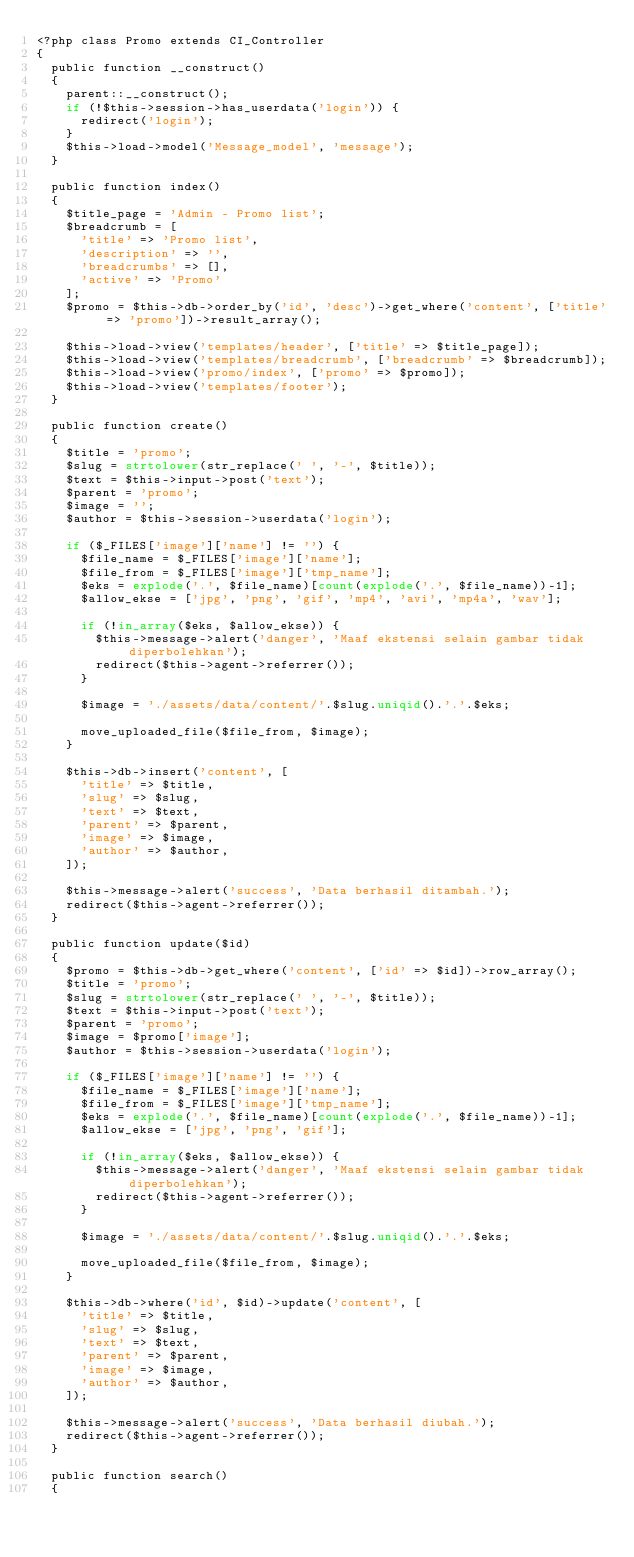Convert code to text. <code><loc_0><loc_0><loc_500><loc_500><_PHP_><?php class Promo extends CI_Controller
{
	public function __construct()
	{
		parent::__construct();
		if (!$this->session->has_userdata('login')) {
			redirect('login');
		}
		$this->load->model('Message_model', 'message');
	}

	public function index()
	{
		$title_page = 'Admin - Promo list';
    $breadcrumb = [
      'title' => 'Promo list',
      'description' => '',
      'breadcrumbs' => [],
      'active' => 'Promo'
    ];
    $promo = $this->db->order_by('id', 'desc')->get_where('content', ['title' => 'promo'])->result_array();

    $this->load->view('templates/header', ['title' => $title_page]);
    $this->load->view('templates/breadcrumb', ['breadcrumb' => $breadcrumb]);
    $this->load->view('promo/index', ['promo' => $promo]);
    $this->load->view('templates/footer');
	}

	public function create()
	{
		$title = 'promo';
		$slug = strtolower(str_replace(' ', '-', $title));
		$text = $this->input->post('text');
		$parent = 'promo';
		$image = '';
		$author = $this->session->userdata('login');

		if ($_FILES['image']['name'] != '') {
			$file_name = $_FILES['image']['name'];
			$file_from = $_FILES['image']['tmp_name'];
			$eks = explode('.', $file_name)[count(explode('.', $file_name))-1];
			$allow_ekse = ['jpg', 'png', 'gif', 'mp4', 'avi', 'mp4a', 'wav'];

			if (!in_array($eks, $allow_ekse)) {
				$this->message->alert('danger', 'Maaf ekstensi selain gambar tidak diperbolehkan');
				redirect($this->agent->referrer());
			}

			$image = './assets/data/content/'.$slug.uniqid().'.'.$eks;

			move_uploaded_file($file_from, $image);
		}

		$this->db->insert('content', [
			'title' => $title,
			'slug' => $slug,
			'text' => $text,
			'parent' => $parent,
			'image' => $image,
			'author' => $author,
		]);

		$this->message->alert('success', 'Data berhasil ditambah.');
		redirect($this->agent->referrer());
	}

	public function update($id)
	{
		$promo = $this->db->get_where('content', ['id' => $id])->row_array();
		$title = 'promo';
		$slug = strtolower(str_replace(' ', '-', $title));
		$text = $this->input->post('text');
		$parent = 'promo';
		$image = $promo['image'];
		$author = $this->session->userdata('login');

		if ($_FILES['image']['name'] != '') {
			$file_name = $_FILES['image']['name'];
			$file_from = $_FILES['image']['tmp_name'];
			$eks = explode('.', $file_name)[count(explode('.', $file_name))-1];
			$allow_ekse = ['jpg', 'png', 'gif'];

			if (!in_array($eks, $allow_ekse)) {
				$this->message->alert('danger', 'Maaf ekstensi selain gambar tidak diperbolehkan');
				redirect($this->agent->referrer());
			}

			$image = './assets/data/content/'.$slug.uniqid().'.'.$eks;

			move_uploaded_file($file_from, $image);
		}

		$this->db->where('id', $id)->update('content', [
			'title' => $title,
			'slug' => $slug,
			'text' => $text,
			'parent' => $parent,
			'image' => $image,
			'author' => $author,
		]);

		$this->message->alert('success', 'Data berhasil diubah.');
		redirect($this->agent->referrer());
	}

	public function search()
	{</code> 